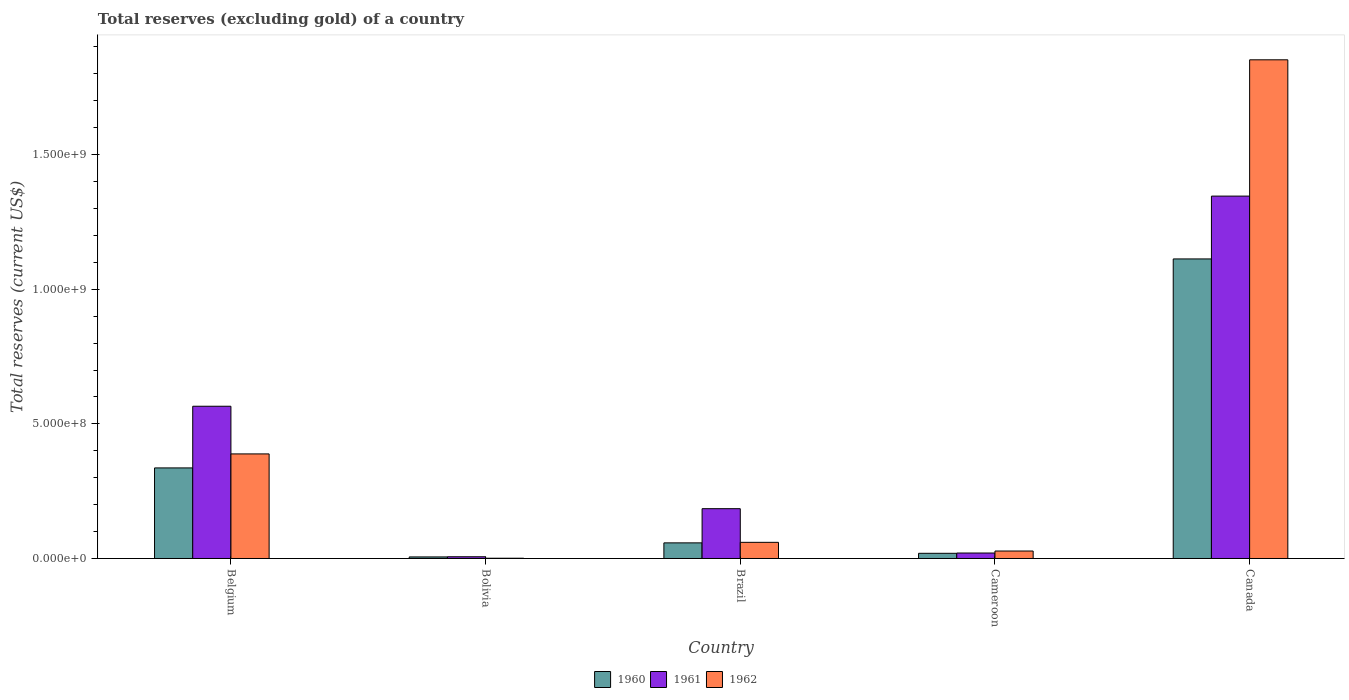Are the number of bars per tick equal to the number of legend labels?
Your response must be concise. Yes. Are the number of bars on each tick of the X-axis equal?
Your answer should be compact. Yes. How many bars are there on the 2nd tick from the left?
Your answer should be compact. 3. What is the total reserves (excluding gold) in 1962 in Bolivia?
Provide a succinct answer. 1.00e+06. Across all countries, what is the maximum total reserves (excluding gold) in 1962?
Ensure brevity in your answer.  1.85e+09. Across all countries, what is the minimum total reserves (excluding gold) in 1962?
Give a very brief answer. 1.00e+06. In which country was the total reserves (excluding gold) in 1962 minimum?
Give a very brief answer. Bolivia. What is the total total reserves (excluding gold) in 1962 in the graph?
Your answer should be compact. 2.33e+09. What is the difference between the total reserves (excluding gold) in 1960 in Belgium and that in Brazil?
Your answer should be compact. 2.78e+08. What is the difference between the total reserves (excluding gold) in 1961 in Cameroon and the total reserves (excluding gold) in 1962 in Bolivia?
Your answer should be compact. 1.93e+07. What is the average total reserves (excluding gold) in 1961 per country?
Ensure brevity in your answer.  4.25e+08. What is the difference between the total reserves (excluding gold) of/in 1961 and total reserves (excluding gold) of/in 1962 in Brazil?
Offer a terse response. 1.25e+08. What is the ratio of the total reserves (excluding gold) in 1962 in Bolivia to that in Cameroon?
Offer a terse response. 0.04. Is the total reserves (excluding gold) in 1961 in Brazil less than that in Cameroon?
Your answer should be compact. No. Is the difference between the total reserves (excluding gold) in 1961 in Cameroon and Canada greater than the difference between the total reserves (excluding gold) in 1962 in Cameroon and Canada?
Provide a succinct answer. Yes. What is the difference between the highest and the second highest total reserves (excluding gold) in 1960?
Your answer should be compact. -2.78e+08. What is the difference between the highest and the lowest total reserves (excluding gold) in 1960?
Make the answer very short. 1.11e+09. What does the 1st bar from the right in Belgium represents?
Your response must be concise. 1962. How many bars are there?
Keep it short and to the point. 15. Are all the bars in the graph horizontal?
Your answer should be compact. No. Does the graph contain grids?
Offer a terse response. No. Where does the legend appear in the graph?
Keep it short and to the point. Bottom center. How many legend labels are there?
Make the answer very short. 3. What is the title of the graph?
Provide a succinct answer. Total reserves (excluding gold) of a country. What is the label or title of the X-axis?
Your answer should be compact. Country. What is the label or title of the Y-axis?
Give a very brief answer. Total reserves (current US$). What is the Total reserves (current US$) of 1960 in Belgium?
Offer a very short reply. 3.36e+08. What is the Total reserves (current US$) in 1961 in Belgium?
Offer a very short reply. 5.65e+08. What is the Total reserves (current US$) of 1962 in Belgium?
Offer a terse response. 3.88e+08. What is the Total reserves (current US$) in 1960 in Bolivia?
Make the answer very short. 5.80e+06. What is the Total reserves (current US$) of 1961 in Bolivia?
Offer a terse response. 6.40e+06. What is the Total reserves (current US$) in 1962 in Bolivia?
Your answer should be very brief. 1.00e+06. What is the Total reserves (current US$) of 1960 in Brazil?
Ensure brevity in your answer.  5.80e+07. What is the Total reserves (current US$) of 1961 in Brazil?
Keep it short and to the point. 1.85e+08. What is the Total reserves (current US$) of 1962 in Brazil?
Keep it short and to the point. 6.00e+07. What is the Total reserves (current US$) of 1960 in Cameroon?
Give a very brief answer. 1.92e+07. What is the Total reserves (current US$) in 1961 in Cameroon?
Make the answer very short. 2.03e+07. What is the Total reserves (current US$) in 1962 in Cameroon?
Your answer should be compact. 2.77e+07. What is the Total reserves (current US$) of 1960 in Canada?
Give a very brief answer. 1.11e+09. What is the Total reserves (current US$) of 1961 in Canada?
Make the answer very short. 1.35e+09. What is the Total reserves (current US$) of 1962 in Canada?
Your answer should be very brief. 1.85e+09. Across all countries, what is the maximum Total reserves (current US$) in 1960?
Give a very brief answer. 1.11e+09. Across all countries, what is the maximum Total reserves (current US$) of 1961?
Keep it short and to the point. 1.35e+09. Across all countries, what is the maximum Total reserves (current US$) of 1962?
Your response must be concise. 1.85e+09. Across all countries, what is the minimum Total reserves (current US$) in 1960?
Your answer should be compact. 5.80e+06. Across all countries, what is the minimum Total reserves (current US$) in 1961?
Provide a short and direct response. 6.40e+06. What is the total Total reserves (current US$) in 1960 in the graph?
Offer a very short reply. 1.53e+09. What is the total Total reserves (current US$) in 1961 in the graph?
Provide a succinct answer. 2.12e+09. What is the total Total reserves (current US$) of 1962 in the graph?
Offer a very short reply. 2.33e+09. What is the difference between the Total reserves (current US$) in 1960 in Belgium and that in Bolivia?
Offer a terse response. 3.31e+08. What is the difference between the Total reserves (current US$) of 1961 in Belgium and that in Bolivia?
Your response must be concise. 5.59e+08. What is the difference between the Total reserves (current US$) of 1962 in Belgium and that in Bolivia?
Your answer should be compact. 3.87e+08. What is the difference between the Total reserves (current US$) in 1960 in Belgium and that in Brazil?
Provide a succinct answer. 2.78e+08. What is the difference between the Total reserves (current US$) in 1961 in Belgium and that in Brazil?
Offer a very short reply. 3.80e+08. What is the difference between the Total reserves (current US$) of 1962 in Belgium and that in Brazil?
Keep it short and to the point. 3.28e+08. What is the difference between the Total reserves (current US$) in 1960 in Belgium and that in Cameroon?
Your response must be concise. 3.17e+08. What is the difference between the Total reserves (current US$) of 1961 in Belgium and that in Cameroon?
Ensure brevity in your answer.  5.45e+08. What is the difference between the Total reserves (current US$) of 1962 in Belgium and that in Cameroon?
Your answer should be very brief. 3.61e+08. What is the difference between the Total reserves (current US$) of 1960 in Belgium and that in Canada?
Your answer should be very brief. -7.76e+08. What is the difference between the Total reserves (current US$) in 1961 in Belgium and that in Canada?
Keep it short and to the point. -7.80e+08. What is the difference between the Total reserves (current US$) in 1962 in Belgium and that in Canada?
Make the answer very short. -1.46e+09. What is the difference between the Total reserves (current US$) of 1960 in Bolivia and that in Brazil?
Offer a very short reply. -5.22e+07. What is the difference between the Total reserves (current US$) of 1961 in Bolivia and that in Brazil?
Give a very brief answer. -1.79e+08. What is the difference between the Total reserves (current US$) of 1962 in Bolivia and that in Brazil?
Make the answer very short. -5.90e+07. What is the difference between the Total reserves (current US$) of 1960 in Bolivia and that in Cameroon?
Offer a very short reply. -1.34e+07. What is the difference between the Total reserves (current US$) in 1961 in Bolivia and that in Cameroon?
Offer a terse response. -1.39e+07. What is the difference between the Total reserves (current US$) in 1962 in Bolivia and that in Cameroon?
Offer a terse response. -2.67e+07. What is the difference between the Total reserves (current US$) in 1960 in Bolivia and that in Canada?
Your answer should be very brief. -1.11e+09. What is the difference between the Total reserves (current US$) of 1961 in Bolivia and that in Canada?
Give a very brief answer. -1.34e+09. What is the difference between the Total reserves (current US$) in 1962 in Bolivia and that in Canada?
Your answer should be very brief. -1.85e+09. What is the difference between the Total reserves (current US$) of 1960 in Brazil and that in Cameroon?
Provide a succinct answer. 3.88e+07. What is the difference between the Total reserves (current US$) of 1961 in Brazil and that in Cameroon?
Offer a terse response. 1.65e+08. What is the difference between the Total reserves (current US$) of 1962 in Brazil and that in Cameroon?
Ensure brevity in your answer.  3.23e+07. What is the difference between the Total reserves (current US$) in 1960 in Brazil and that in Canada?
Provide a short and direct response. -1.05e+09. What is the difference between the Total reserves (current US$) in 1961 in Brazil and that in Canada?
Your answer should be very brief. -1.16e+09. What is the difference between the Total reserves (current US$) of 1962 in Brazil and that in Canada?
Provide a short and direct response. -1.79e+09. What is the difference between the Total reserves (current US$) of 1960 in Cameroon and that in Canada?
Your response must be concise. -1.09e+09. What is the difference between the Total reserves (current US$) of 1961 in Cameroon and that in Canada?
Ensure brevity in your answer.  -1.33e+09. What is the difference between the Total reserves (current US$) of 1962 in Cameroon and that in Canada?
Give a very brief answer. -1.82e+09. What is the difference between the Total reserves (current US$) of 1960 in Belgium and the Total reserves (current US$) of 1961 in Bolivia?
Offer a very short reply. 3.30e+08. What is the difference between the Total reserves (current US$) in 1960 in Belgium and the Total reserves (current US$) in 1962 in Bolivia?
Offer a terse response. 3.35e+08. What is the difference between the Total reserves (current US$) in 1961 in Belgium and the Total reserves (current US$) in 1962 in Bolivia?
Offer a very short reply. 5.64e+08. What is the difference between the Total reserves (current US$) in 1960 in Belgium and the Total reserves (current US$) in 1961 in Brazil?
Provide a short and direct response. 1.51e+08. What is the difference between the Total reserves (current US$) in 1960 in Belgium and the Total reserves (current US$) in 1962 in Brazil?
Keep it short and to the point. 2.76e+08. What is the difference between the Total reserves (current US$) in 1961 in Belgium and the Total reserves (current US$) in 1962 in Brazil?
Your answer should be compact. 5.05e+08. What is the difference between the Total reserves (current US$) of 1960 in Belgium and the Total reserves (current US$) of 1961 in Cameroon?
Provide a succinct answer. 3.16e+08. What is the difference between the Total reserves (current US$) in 1960 in Belgium and the Total reserves (current US$) in 1962 in Cameroon?
Your answer should be compact. 3.09e+08. What is the difference between the Total reserves (current US$) in 1961 in Belgium and the Total reserves (current US$) in 1962 in Cameroon?
Offer a very short reply. 5.38e+08. What is the difference between the Total reserves (current US$) of 1960 in Belgium and the Total reserves (current US$) of 1961 in Canada?
Make the answer very short. -1.01e+09. What is the difference between the Total reserves (current US$) in 1960 in Belgium and the Total reserves (current US$) in 1962 in Canada?
Provide a succinct answer. -1.52e+09. What is the difference between the Total reserves (current US$) in 1961 in Belgium and the Total reserves (current US$) in 1962 in Canada?
Your response must be concise. -1.29e+09. What is the difference between the Total reserves (current US$) in 1960 in Bolivia and the Total reserves (current US$) in 1961 in Brazil?
Give a very brief answer. -1.79e+08. What is the difference between the Total reserves (current US$) of 1960 in Bolivia and the Total reserves (current US$) of 1962 in Brazil?
Your response must be concise. -5.42e+07. What is the difference between the Total reserves (current US$) of 1961 in Bolivia and the Total reserves (current US$) of 1962 in Brazil?
Ensure brevity in your answer.  -5.36e+07. What is the difference between the Total reserves (current US$) of 1960 in Bolivia and the Total reserves (current US$) of 1961 in Cameroon?
Offer a terse response. -1.45e+07. What is the difference between the Total reserves (current US$) in 1960 in Bolivia and the Total reserves (current US$) in 1962 in Cameroon?
Offer a very short reply. -2.19e+07. What is the difference between the Total reserves (current US$) of 1961 in Bolivia and the Total reserves (current US$) of 1962 in Cameroon?
Give a very brief answer. -2.13e+07. What is the difference between the Total reserves (current US$) in 1960 in Bolivia and the Total reserves (current US$) in 1961 in Canada?
Provide a short and direct response. -1.34e+09. What is the difference between the Total reserves (current US$) of 1960 in Bolivia and the Total reserves (current US$) of 1962 in Canada?
Keep it short and to the point. -1.85e+09. What is the difference between the Total reserves (current US$) in 1961 in Bolivia and the Total reserves (current US$) in 1962 in Canada?
Your answer should be compact. -1.85e+09. What is the difference between the Total reserves (current US$) in 1960 in Brazil and the Total reserves (current US$) in 1961 in Cameroon?
Ensure brevity in your answer.  3.77e+07. What is the difference between the Total reserves (current US$) in 1960 in Brazil and the Total reserves (current US$) in 1962 in Cameroon?
Ensure brevity in your answer.  3.03e+07. What is the difference between the Total reserves (current US$) in 1961 in Brazil and the Total reserves (current US$) in 1962 in Cameroon?
Offer a terse response. 1.57e+08. What is the difference between the Total reserves (current US$) in 1960 in Brazil and the Total reserves (current US$) in 1961 in Canada?
Ensure brevity in your answer.  -1.29e+09. What is the difference between the Total reserves (current US$) in 1960 in Brazil and the Total reserves (current US$) in 1962 in Canada?
Your answer should be compact. -1.79e+09. What is the difference between the Total reserves (current US$) in 1961 in Brazil and the Total reserves (current US$) in 1962 in Canada?
Provide a succinct answer. -1.67e+09. What is the difference between the Total reserves (current US$) of 1960 in Cameroon and the Total reserves (current US$) of 1961 in Canada?
Your response must be concise. -1.33e+09. What is the difference between the Total reserves (current US$) in 1960 in Cameroon and the Total reserves (current US$) in 1962 in Canada?
Ensure brevity in your answer.  -1.83e+09. What is the difference between the Total reserves (current US$) of 1961 in Cameroon and the Total reserves (current US$) of 1962 in Canada?
Offer a very short reply. -1.83e+09. What is the average Total reserves (current US$) in 1960 per country?
Make the answer very short. 3.06e+08. What is the average Total reserves (current US$) in 1961 per country?
Provide a succinct answer. 4.25e+08. What is the average Total reserves (current US$) of 1962 per country?
Your answer should be compact. 4.66e+08. What is the difference between the Total reserves (current US$) of 1960 and Total reserves (current US$) of 1961 in Belgium?
Make the answer very short. -2.29e+08. What is the difference between the Total reserves (current US$) of 1960 and Total reserves (current US$) of 1962 in Belgium?
Offer a terse response. -5.20e+07. What is the difference between the Total reserves (current US$) in 1961 and Total reserves (current US$) in 1962 in Belgium?
Offer a very short reply. 1.77e+08. What is the difference between the Total reserves (current US$) of 1960 and Total reserves (current US$) of 1961 in Bolivia?
Ensure brevity in your answer.  -6.00e+05. What is the difference between the Total reserves (current US$) in 1960 and Total reserves (current US$) in 1962 in Bolivia?
Your answer should be compact. 4.80e+06. What is the difference between the Total reserves (current US$) in 1961 and Total reserves (current US$) in 1962 in Bolivia?
Give a very brief answer. 5.40e+06. What is the difference between the Total reserves (current US$) in 1960 and Total reserves (current US$) in 1961 in Brazil?
Keep it short and to the point. -1.27e+08. What is the difference between the Total reserves (current US$) of 1961 and Total reserves (current US$) of 1962 in Brazil?
Your answer should be compact. 1.25e+08. What is the difference between the Total reserves (current US$) in 1960 and Total reserves (current US$) in 1961 in Cameroon?
Your answer should be compact. -1.06e+06. What is the difference between the Total reserves (current US$) in 1960 and Total reserves (current US$) in 1962 in Cameroon?
Your response must be concise. -8.47e+06. What is the difference between the Total reserves (current US$) of 1961 and Total reserves (current US$) of 1962 in Cameroon?
Offer a terse response. -7.41e+06. What is the difference between the Total reserves (current US$) of 1960 and Total reserves (current US$) of 1961 in Canada?
Give a very brief answer. -2.33e+08. What is the difference between the Total reserves (current US$) in 1960 and Total reserves (current US$) in 1962 in Canada?
Your answer should be very brief. -7.39e+08. What is the difference between the Total reserves (current US$) in 1961 and Total reserves (current US$) in 1962 in Canada?
Give a very brief answer. -5.06e+08. What is the ratio of the Total reserves (current US$) of 1960 in Belgium to that in Bolivia?
Your answer should be very brief. 58. What is the ratio of the Total reserves (current US$) in 1961 in Belgium to that in Bolivia?
Provide a short and direct response. 88.34. What is the ratio of the Total reserves (current US$) of 1962 in Belgium to that in Bolivia?
Provide a short and direct response. 388.39. What is the ratio of the Total reserves (current US$) of 1960 in Belgium to that in Brazil?
Offer a very short reply. 5.8. What is the ratio of the Total reserves (current US$) in 1961 in Belgium to that in Brazil?
Your response must be concise. 3.06. What is the ratio of the Total reserves (current US$) of 1962 in Belgium to that in Brazil?
Give a very brief answer. 6.47. What is the ratio of the Total reserves (current US$) in 1960 in Belgium to that in Cameroon?
Provide a short and direct response. 17.48. What is the ratio of the Total reserves (current US$) of 1961 in Belgium to that in Cameroon?
Provide a short and direct response. 27.85. What is the ratio of the Total reserves (current US$) of 1962 in Belgium to that in Cameroon?
Give a very brief answer. 14.02. What is the ratio of the Total reserves (current US$) in 1960 in Belgium to that in Canada?
Give a very brief answer. 0.3. What is the ratio of the Total reserves (current US$) in 1961 in Belgium to that in Canada?
Make the answer very short. 0.42. What is the ratio of the Total reserves (current US$) of 1962 in Belgium to that in Canada?
Give a very brief answer. 0.21. What is the ratio of the Total reserves (current US$) in 1960 in Bolivia to that in Brazil?
Provide a short and direct response. 0.1. What is the ratio of the Total reserves (current US$) of 1961 in Bolivia to that in Brazil?
Give a very brief answer. 0.03. What is the ratio of the Total reserves (current US$) in 1962 in Bolivia to that in Brazil?
Ensure brevity in your answer.  0.02. What is the ratio of the Total reserves (current US$) in 1960 in Bolivia to that in Cameroon?
Make the answer very short. 0.3. What is the ratio of the Total reserves (current US$) of 1961 in Bolivia to that in Cameroon?
Your answer should be compact. 0.32. What is the ratio of the Total reserves (current US$) in 1962 in Bolivia to that in Cameroon?
Give a very brief answer. 0.04. What is the ratio of the Total reserves (current US$) of 1960 in Bolivia to that in Canada?
Ensure brevity in your answer.  0.01. What is the ratio of the Total reserves (current US$) of 1961 in Bolivia to that in Canada?
Give a very brief answer. 0. What is the ratio of the Total reserves (current US$) of 1962 in Bolivia to that in Canada?
Provide a short and direct response. 0. What is the ratio of the Total reserves (current US$) in 1960 in Brazil to that in Cameroon?
Your response must be concise. 3.01. What is the ratio of the Total reserves (current US$) in 1961 in Brazil to that in Cameroon?
Offer a terse response. 9.11. What is the ratio of the Total reserves (current US$) of 1962 in Brazil to that in Cameroon?
Provide a short and direct response. 2.17. What is the ratio of the Total reserves (current US$) in 1960 in Brazil to that in Canada?
Keep it short and to the point. 0.05. What is the ratio of the Total reserves (current US$) in 1961 in Brazil to that in Canada?
Your response must be concise. 0.14. What is the ratio of the Total reserves (current US$) in 1962 in Brazil to that in Canada?
Ensure brevity in your answer.  0.03. What is the ratio of the Total reserves (current US$) of 1960 in Cameroon to that in Canada?
Give a very brief answer. 0.02. What is the ratio of the Total reserves (current US$) in 1961 in Cameroon to that in Canada?
Offer a terse response. 0.02. What is the ratio of the Total reserves (current US$) of 1962 in Cameroon to that in Canada?
Your response must be concise. 0.01. What is the difference between the highest and the second highest Total reserves (current US$) in 1960?
Give a very brief answer. 7.76e+08. What is the difference between the highest and the second highest Total reserves (current US$) of 1961?
Provide a short and direct response. 7.80e+08. What is the difference between the highest and the second highest Total reserves (current US$) of 1962?
Your response must be concise. 1.46e+09. What is the difference between the highest and the lowest Total reserves (current US$) of 1960?
Your response must be concise. 1.11e+09. What is the difference between the highest and the lowest Total reserves (current US$) in 1961?
Make the answer very short. 1.34e+09. What is the difference between the highest and the lowest Total reserves (current US$) in 1962?
Offer a terse response. 1.85e+09. 